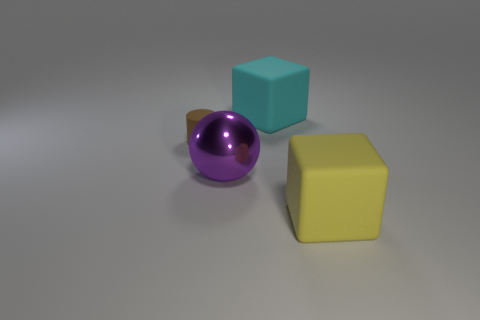Is there any other thing that has the same material as the yellow cube?
Your answer should be compact. Yes. Is the material of the big cyan cube the same as the large yellow cube that is in front of the purple thing?
Offer a very short reply. Yes. Is the number of blocks that are behind the small rubber cylinder less than the number of big objects in front of the big cyan object?
Make the answer very short. Yes. What is the large block that is behind the matte cylinder made of?
Your response must be concise. Rubber. There is a object that is behind the big purple metal ball and to the right of the purple metal object; what is its color?
Give a very brief answer. Cyan. How many other things are there of the same color as the small rubber cylinder?
Your response must be concise. 0. There is a large rubber object that is in front of the large sphere; what is its color?
Provide a short and direct response. Yellow. Is there a purple metal thing that has the same size as the yellow rubber cube?
Make the answer very short. Yes. What material is the cyan block that is the same size as the purple ball?
Make the answer very short. Rubber. What number of things are rubber things in front of the big purple thing or matte cubes in front of the brown object?
Make the answer very short. 1. 